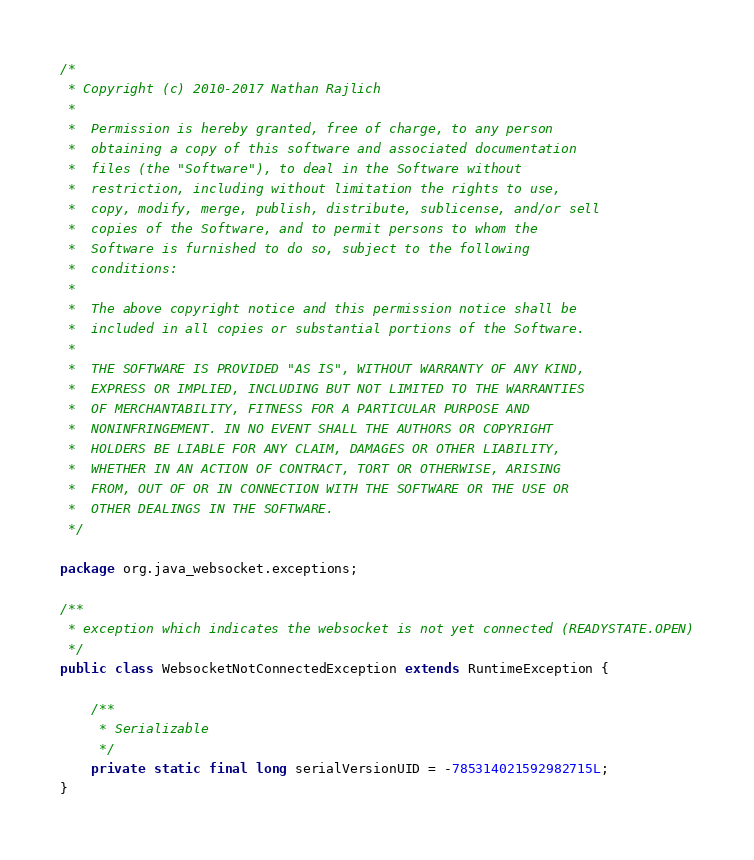Convert code to text. <code><loc_0><loc_0><loc_500><loc_500><_Java_>/*
 * Copyright (c) 2010-2017 Nathan Rajlich
 *
 *  Permission is hereby granted, free of charge, to any person
 *  obtaining a copy of this software and associated documentation
 *  files (the "Software"), to deal in the Software without
 *  restriction, including without limitation the rights to use,
 *  copy, modify, merge, publish, distribute, sublicense, and/or sell
 *  copies of the Software, and to permit persons to whom the
 *  Software is furnished to do so, subject to the following
 *  conditions:
 *
 *  The above copyright notice and this permission notice shall be
 *  included in all copies or substantial portions of the Software.
 *
 *  THE SOFTWARE IS PROVIDED "AS IS", WITHOUT WARRANTY OF ANY KIND,
 *  EXPRESS OR IMPLIED, INCLUDING BUT NOT LIMITED TO THE WARRANTIES
 *  OF MERCHANTABILITY, FITNESS FOR A PARTICULAR PURPOSE AND
 *  NONINFRINGEMENT. IN NO EVENT SHALL THE AUTHORS OR COPYRIGHT
 *  HOLDERS BE LIABLE FOR ANY CLAIM, DAMAGES OR OTHER LIABILITY,
 *  WHETHER IN AN ACTION OF CONTRACT, TORT OR OTHERWISE, ARISING
 *  FROM, OUT OF OR IN CONNECTION WITH THE SOFTWARE OR THE USE OR
 *  OTHER DEALINGS IN THE SOFTWARE.
 */

package org.java_websocket.exceptions;

/**
 * exception which indicates the websocket is not yet connected (READYSTATE.OPEN)
 */
public class WebsocketNotConnectedException extends RuntimeException {

    /**
     * Serializable
     */
    private static final long serialVersionUID = -785314021592982715L;
}
</code> 